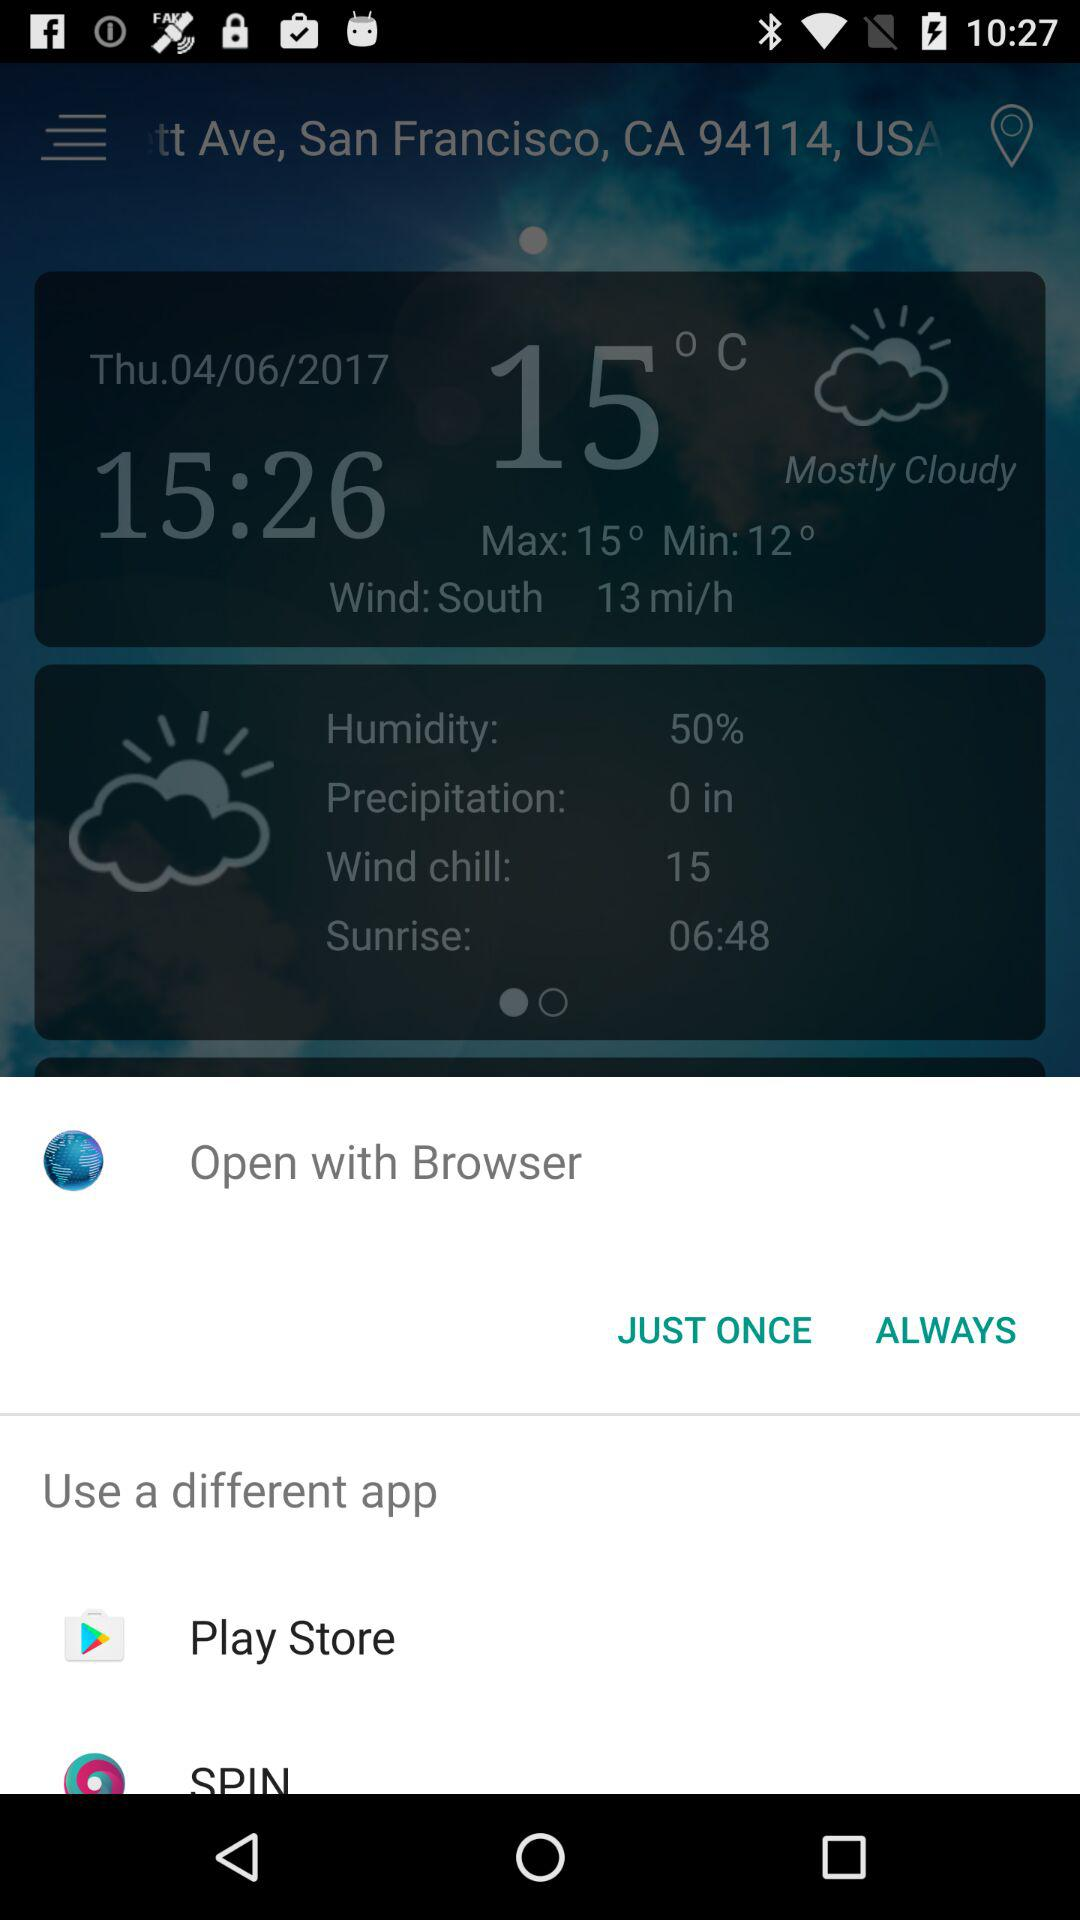Through which applications can we open it? You can open it through "Play Store" and "SPIN". 